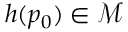Convert formula to latex. <formula><loc_0><loc_0><loc_500><loc_500>h ( p _ { 0 } ) \in \mathcal { M }</formula> 